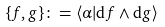Convert formula to latex. <formula><loc_0><loc_0><loc_500><loc_500>\{ f , g \} \colon = \langle \alpha | \mathrm d f \wedge \mathrm d g \rangle</formula> 